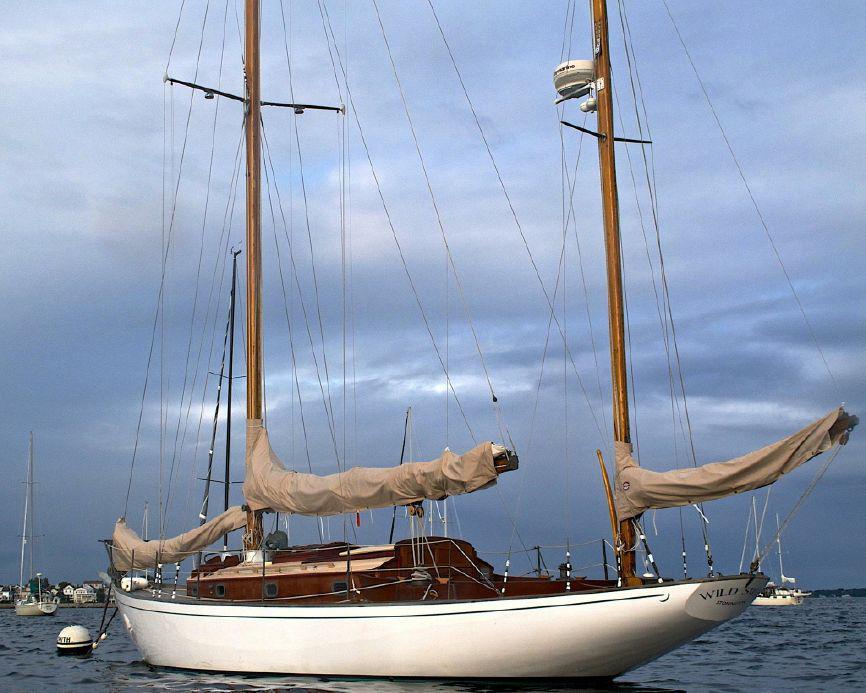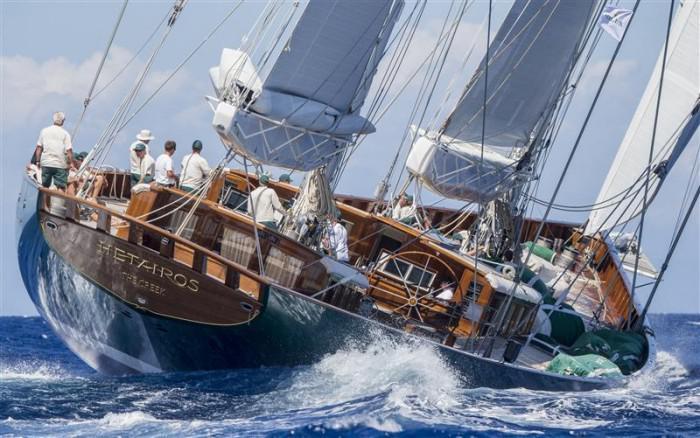The first image is the image on the left, the second image is the image on the right. Examine the images to the left and right. Is the description "the sails are furled in the image on the right" accurate? Answer yes or no. No. The first image is the image on the left, the second image is the image on the right. For the images displayed, is the sentence "All boat sails are furled." factually correct? Answer yes or no. No. 